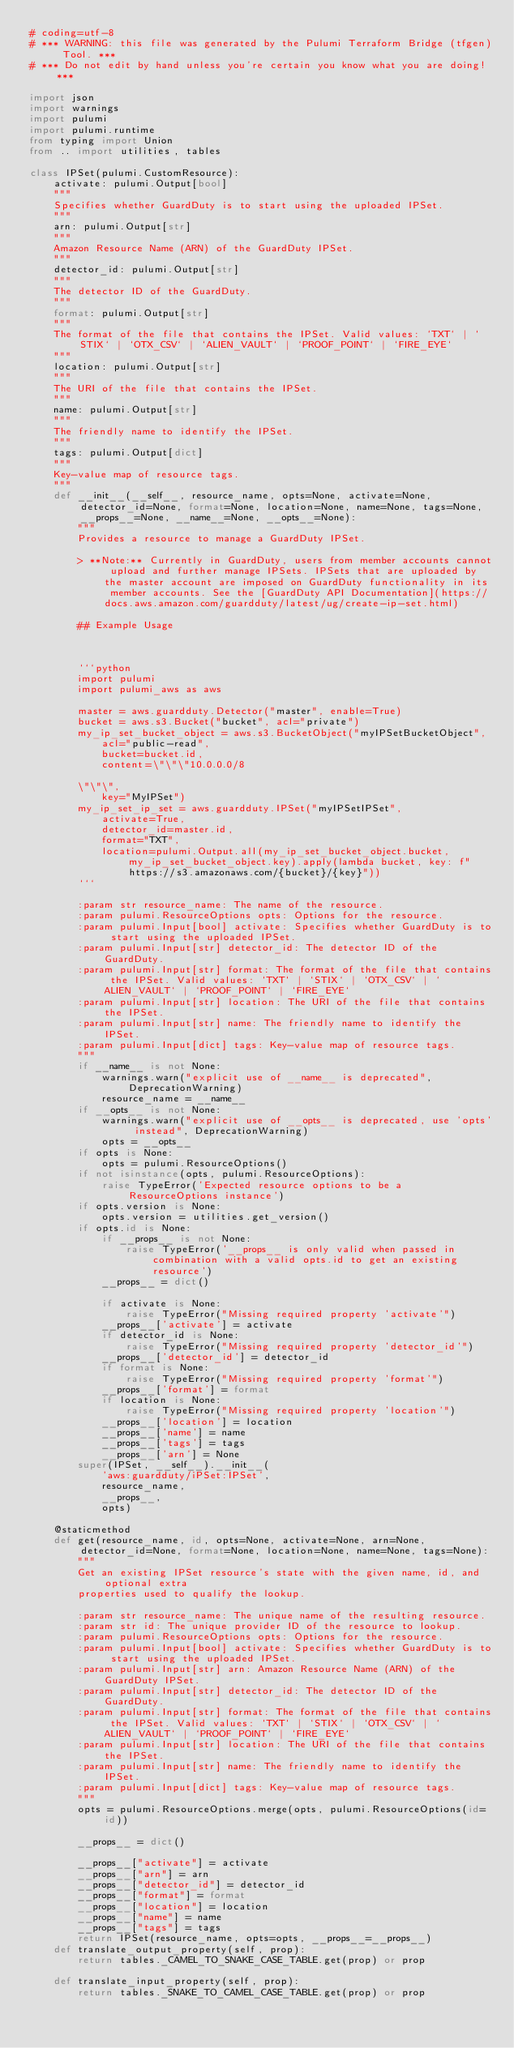Convert code to text. <code><loc_0><loc_0><loc_500><loc_500><_Python_># coding=utf-8
# *** WARNING: this file was generated by the Pulumi Terraform Bridge (tfgen) Tool. ***
# *** Do not edit by hand unless you're certain you know what you are doing! ***

import json
import warnings
import pulumi
import pulumi.runtime
from typing import Union
from .. import utilities, tables

class IPSet(pulumi.CustomResource):
    activate: pulumi.Output[bool]
    """
    Specifies whether GuardDuty is to start using the uploaded IPSet.
    """
    arn: pulumi.Output[str]
    """
    Amazon Resource Name (ARN) of the GuardDuty IPSet.
    """
    detector_id: pulumi.Output[str]
    """
    The detector ID of the GuardDuty.
    """
    format: pulumi.Output[str]
    """
    The format of the file that contains the IPSet. Valid values: `TXT` | `STIX` | `OTX_CSV` | `ALIEN_VAULT` | `PROOF_POINT` | `FIRE_EYE`
    """
    location: pulumi.Output[str]
    """
    The URI of the file that contains the IPSet.
    """
    name: pulumi.Output[str]
    """
    The friendly name to identify the IPSet.
    """
    tags: pulumi.Output[dict]
    """
    Key-value map of resource tags.
    """
    def __init__(__self__, resource_name, opts=None, activate=None, detector_id=None, format=None, location=None, name=None, tags=None, __props__=None, __name__=None, __opts__=None):
        """
        Provides a resource to manage a GuardDuty IPSet.

        > **Note:** Currently in GuardDuty, users from member accounts cannot upload and further manage IPSets. IPSets that are uploaded by the master account are imposed on GuardDuty functionality in its member accounts. See the [GuardDuty API Documentation](https://docs.aws.amazon.com/guardduty/latest/ug/create-ip-set.html)

        ## Example Usage



        ```python
        import pulumi
        import pulumi_aws as aws

        master = aws.guardduty.Detector("master", enable=True)
        bucket = aws.s3.Bucket("bucket", acl="private")
        my_ip_set_bucket_object = aws.s3.BucketObject("myIPSetBucketObject",
            acl="public-read",
            bucket=bucket.id,
            content=\"\"\"10.0.0.0/8

        \"\"\",
            key="MyIPSet")
        my_ip_set_ip_set = aws.guardduty.IPSet("myIPSetIPSet",
            activate=True,
            detector_id=master.id,
            format="TXT",
            location=pulumi.Output.all(my_ip_set_bucket_object.bucket, my_ip_set_bucket_object.key).apply(lambda bucket, key: f"https://s3.amazonaws.com/{bucket}/{key}"))
        ```

        :param str resource_name: The name of the resource.
        :param pulumi.ResourceOptions opts: Options for the resource.
        :param pulumi.Input[bool] activate: Specifies whether GuardDuty is to start using the uploaded IPSet.
        :param pulumi.Input[str] detector_id: The detector ID of the GuardDuty.
        :param pulumi.Input[str] format: The format of the file that contains the IPSet. Valid values: `TXT` | `STIX` | `OTX_CSV` | `ALIEN_VAULT` | `PROOF_POINT` | `FIRE_EYE`
        :param pulumi.Input[str] location: The URI of the file that contains the IPSet.
        :param pulumi.Input[str] name: The friendly name to identify the IPSet.
        :param pulumi.Input[dict] tags: Key-value map of resource tags.
        """
        if __name__ is not None:
            warnings.warn("explicit use of __name__ is deprecated", DeprecationWarning)
            resource_name = __name__
        if __opts__ is not None:
            warnings.warn("explicit use of __opts__ is deprecated, use 'opts' instead", DeprecationWarning)
            opts = __opts__
        if opts is None:
            opts = pulumi.ResourceOptions()
        if not isinstance(opts, pulumi.ResourceOptions):
            raise TypeError('Expected resource options to be a ResourceOptions instance')
        if opts.version is None:
            opts.version = utilities.get_version()
        if opts.id is None:
            if __props__ is not None:
                raise TypeError('__props__ is only valid when passed in combination with a valid opts.id to get an existing resource')
            __props__ = dict()

            if activate is None:
                raise TypeError("Missing required property 'activate'")
            __props__['activate'] = activate
            if detector_id is None:
                raise TypeError("Missing required property 'detector_id'")
            __props__['detector_id'] = detector_id
            if format is None:
                raise TypeError("Missing required property 'format'")
            __props__['format'] = format
            if location is None:
                raise TypeError("Missing required property 'location'")
            __props__['location'] = location
            __props__['name'] = name
            __props__['tags'] = tags
            __props__['arn'] = None
        super(IPSet, __self__).__init__(
            'aws:guardduty/iPSet:IPSet',
            resource_name,
            __props__,
            opts)

    @staticmethod
    def get(resource_name, id, opts=None, activate=None, arn=None, detector_id=None, format=None, location=None, name=None, tags=None):
        """
        Get an existing IPSet resource's state with the given name, id, and optional extra
        properties used to qualify the lookup.

        :param str resource_name: The unique name of the resulting resource.
        :param str id: The unique provider ID of the resource to lookup.
        :param pulumi.ResourceOptions opts: Options for the resource.
        :param pulumi.Input[bool] activate: Specifies whether GuardDuty is to start using the uploaded IPSet.
        :param pulumi.Input[str] arn: Amazon Resource Name (ARN) of the GuardDuty IPSet.
        :param pulumi.Input[str] detector_id: The detector ID of the GuardDuty.
        :param pulumi.Input[str] format: The format of the file that contains the IPSet. Valid values: `TXT` | `STIX` | `OTX_CSV` | `ALIEN_VAULT` | `PROOF_POINT` | `FIRE_EYE`
        :param pulumi.Input[str] location: The URI of the file that contains the IPSet.
        :param pulumi.Input[str] name: The friendly name to identify the IPSet.
        :param pulumi.Input[dict] tags: Key-value map of resource tags.
        """
        opts = pulumi.ResourceOptions.merge(opts, pulumi.ResourceOptions(id=id))

        __props__ = dict()

        __props__["activate"] = activate
        __props__["arn"] = arn
        __props__["detector_id"] = detector_id
        __props__["format"] = format
        __props__["location"] = location
        __props__["name"] = name
        __props__["tags"] = tags
        return IPSet(resource_name, opts=opts, __props__=__props__)
    def translate_output_property(self, prop):
        return tables._CAMEL_TO_SNAKE_CASE_TABLE.get(prop) or prop

    def translate_input_property(self, prop):
        return tables._SNAKE_TO_CAMEL_CASE_TABLE.get(prop) or prop

</code> 